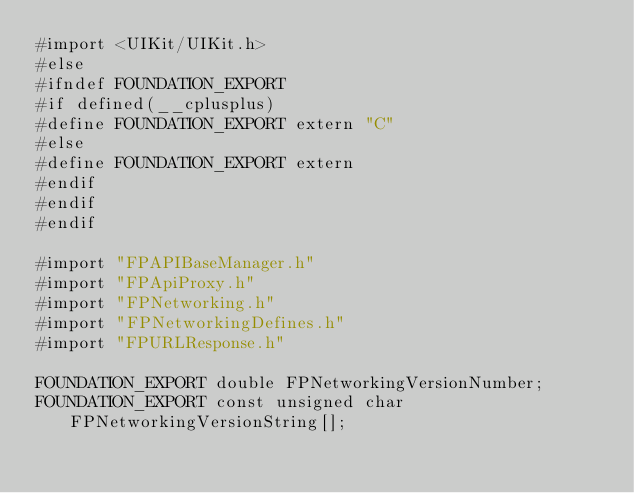Convert code to text. <code><loc_0><loc_0><loc_500><loc_500><_C_>#import <UIKit/UIKit.h>
#else
#ifndef FOUNDATION_EXPORT
#if defined(__cplusplus)
#define FOUNDATION_EXPORT extern "C"
#else
#define FOUNDATION_EXPORT extern
#endif
#endif
#endif

#import "FPAPIBaseManager.h"
#import "FPApiProxy.h"
#import "FPNetworking.h"
#import "FPNetworkingDefines.h"
#import "FPURLResponse.h"

FOUNDATION_EXPORT double FPNetworkingVersionNumber;
FOUNDATION_EXPORT const unsigned char FPNetworkingVersionString[];

</code> 